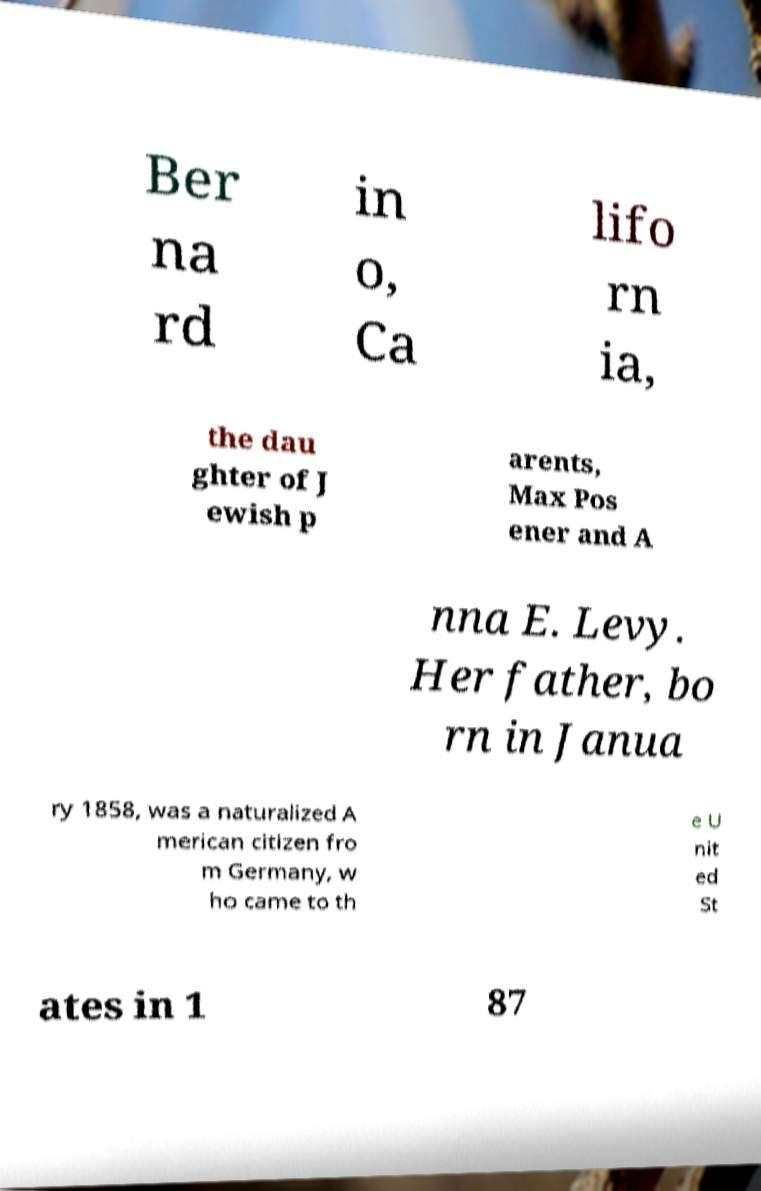Please identify and transcribe the text found in this image. Ber na rd in o, Ca lifo rn ia, the dau ghter of J ewish p arents, Max Pos ener and A nna E. Levy. Her father, bo rn in Janua ry 1858, was a naturalized A merican citizen fro m Germany, w ho came to th e U nit ed St ates in 1 87 